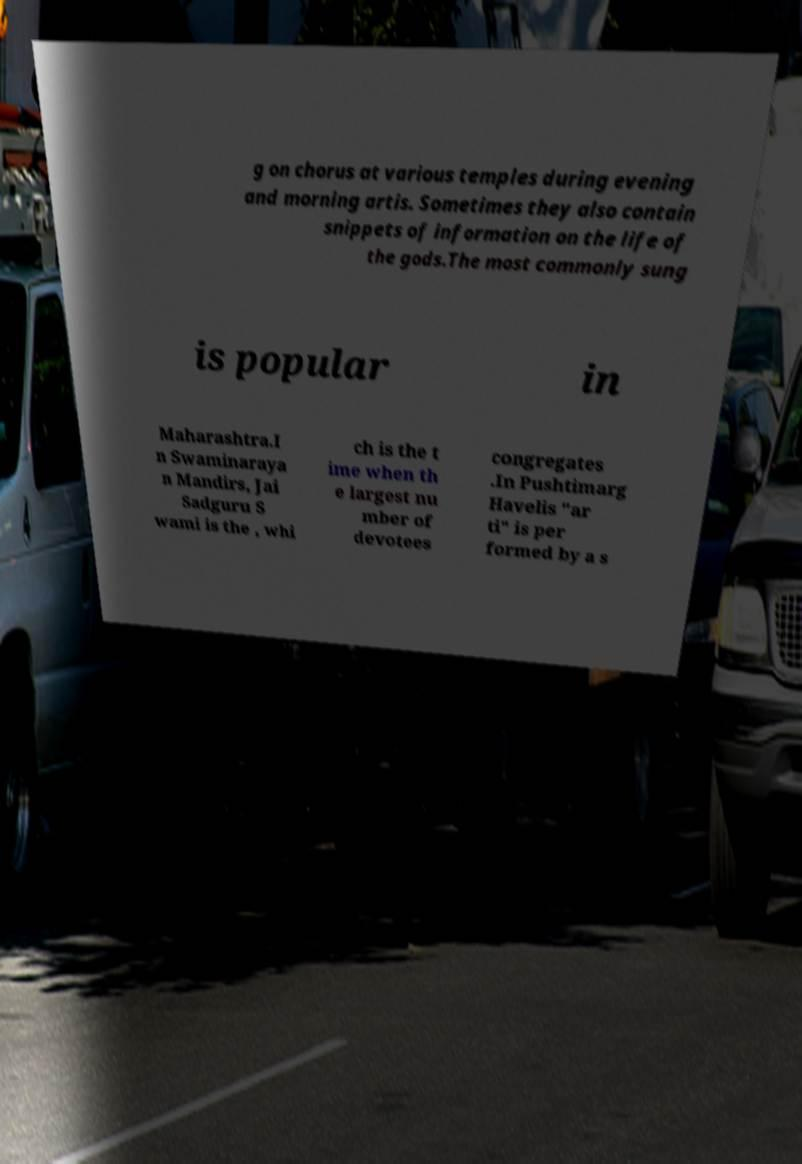Please identify and transcribe the text found in this image. g on chorus at various temples during evening and morning artis. Sometimes they also contain snippets of information on the life of the gods.The most commonly sung is popular in Maharashtra.I n Swaminaraya n Mandirs, Jai Sadguru S wami is the , whi ch is the t ime when th e largest nu mber of devotees congregates .In Pushtimarg Havelis "ar ti" is per formed by a s 